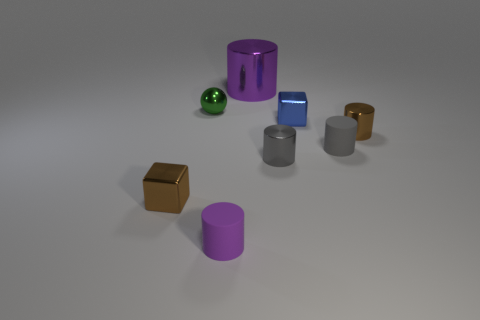Are there any other things that are the same shape as the small green metal object?
Ensure brevity in your answer.  No. What number of purple metallic objects are there?
Give a very brief answer. 1. Are there any other things that are the same size as the purple shiny cylinder?
Provide a short and direct response. No. Does the green thing have the same material as the small purple cylinder?
Make the answer very short. No. Does the brown thing that is left of the tiny purple rubber thing have the same size as the purple object that is behind the blue metallic object?
Keep it short and to the point. No. Is the number of balls less than the number of big brown balls?
Give a very brief answer. No. What number of matte things are brown blocks or purple things?
Your answer should be compact. 1. Are there any brown objects that are in front of the gray thing that is on the right side of the tiny blue cube?
Keep it short and to the point. Yes. Are the tiny cube that is left of the purple shiny object and the large thing made of the same material?
Give a very brief answer. Yes. How many other objects are the same color as the big cylinder?
Offer a terse response. 1. 